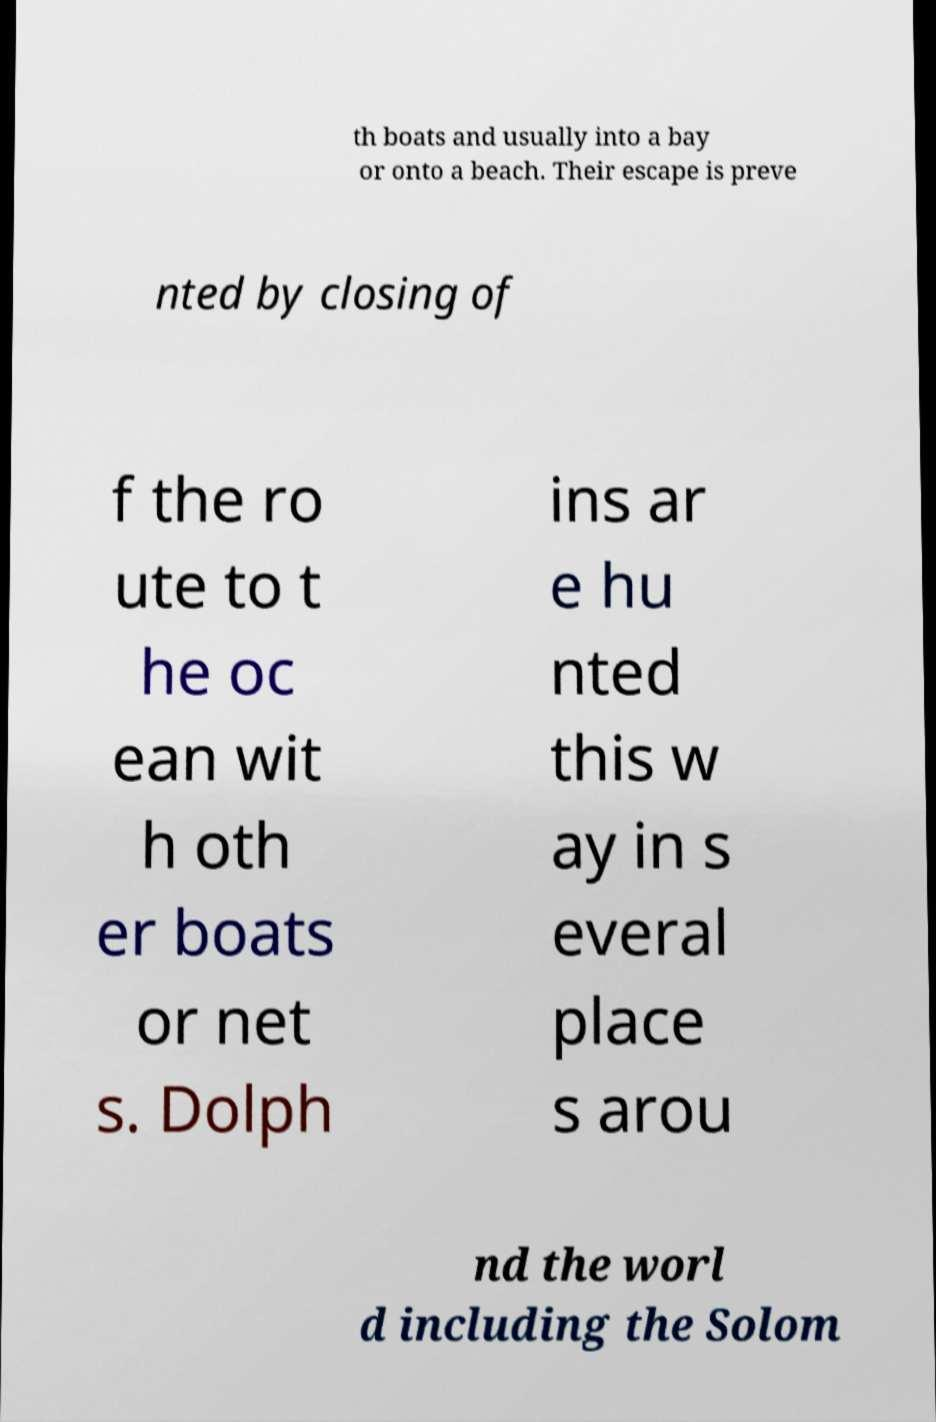Please read and relay the text visible in this image. What does it say? th boats and usually into a bay or onto a beach. Their escape is preve nted by closing of f the ro ute to t he oc ean wit h oth er boats or net s. Dolph ins ar e hu nted this w ay in s everal place s arou nd the worl d including the Solom 